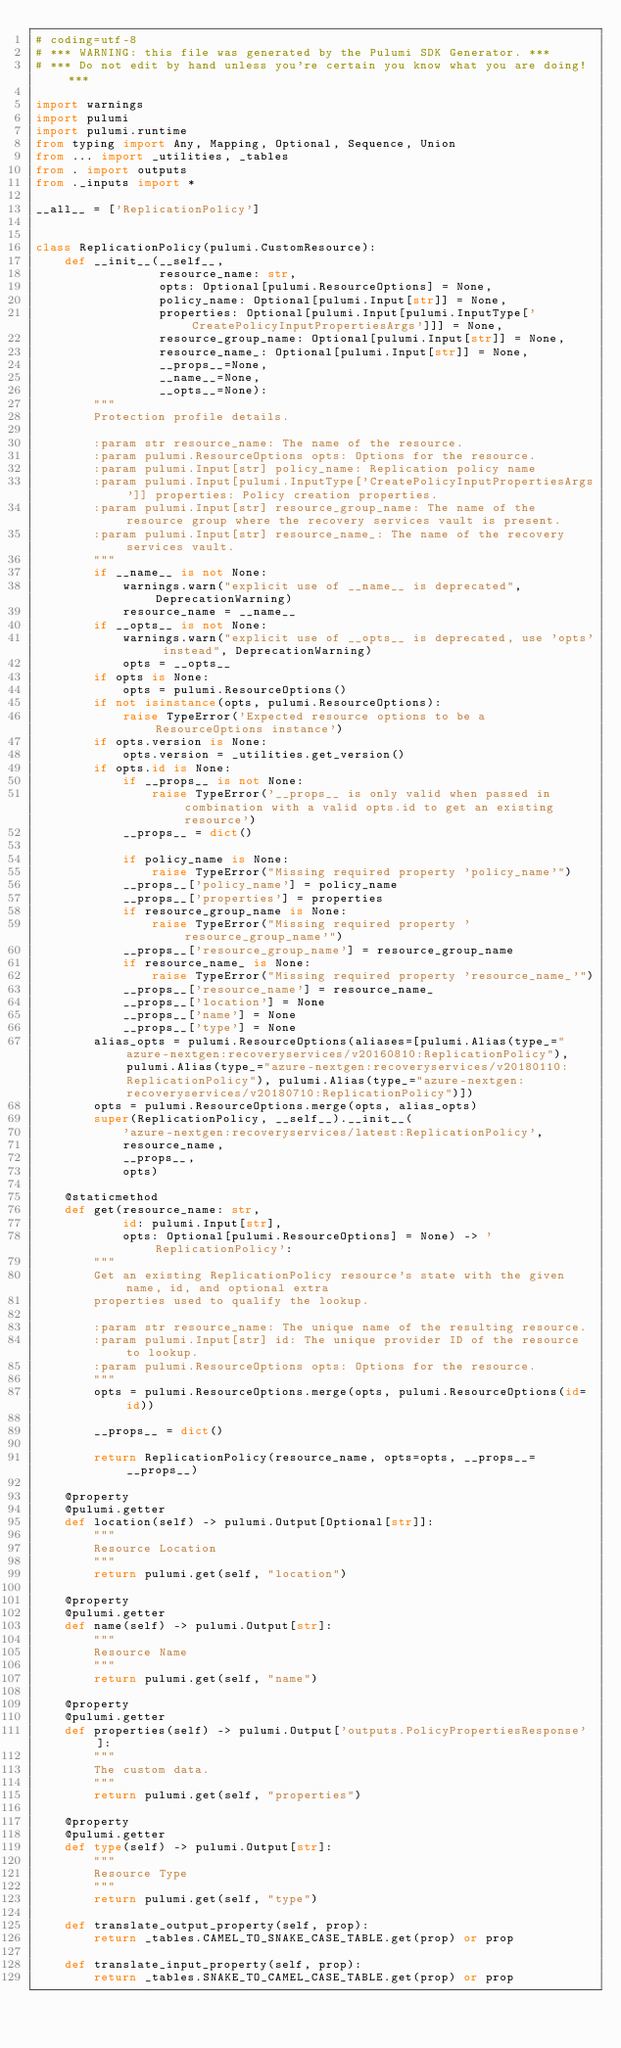<code> <loc_0><loc_0><loc_500><loc_500><_Python_># coding=utf-8
# *** WARNING: this file was generated by the Pulumi SDK Generator. ***
# *** Do not edit by hand unless you're certain you know what you are doing! ***

import warnings
import pulumi
import pulumi.runtime
from typing import Any, Mapping, Optional, Sequence, Union
from ... import _utilities, _tables
from . import outputs
from ._inputs import *

__all__ = ['ReplicationPolicy']


class ReplicationPolicy(pulumi.CustomResource):
    def __init__(__self__,
                 resource_name: str,
                 opts: Optional[pulumi.ResourceOptions] = None,
                 policy_name: Optional[pulumi.Input[str]] = None,
                 properties: Optional[pulumi.Input[pulumi.InputType['CreatePolicyInputPropertiesArgs']]] = None,
                 resource_group_name: Optional[pulumi.Input[str]] = None,
                 resource_name_: Optional[pulumi.Input[str]] = None,
                 __props__=None,
                 __name__=None,
                 __opts__=None):
        """
        Protection profile details.

        :param str resource_name: The name of the resource.
        :param pulumi.ResourceOptions opts: Options for the resource.
        :param pulumi.Input[str] policy_name: Replication policy name
        :param pulumi.Input[pulumi.InputType['CreatePolicyInputPropertiesArgs']] properties: Policy creation properties.
        :param pulumi.Input[str] resource_group_name: The name of the resource group where the recovery services vault is present.
        :param pulumi.Input[str] resource_name_: The name of the recovery services vault.
        """
        if __name__ is not None:
            warnings.warn("explicit use of __name__ is deprecated", DeprecationWarning)
            resource_name = __name__
        if __opts__ is not None:
            warnings.warn("explicit use of __opts__ is deprecated, use 'opts' instead", DeprecationWarning)
            opts = __opts__
        if opts is None:
            opts = pulumi.ResourceOptions()
        if not isinstance(opts, pulumi.ResourceOptions):
            raise TypeError('Expected resource options to be a ResourceOptions instance')
        if opts.version is None:
            opts.version = _utilities.get_version()
        if opts.id is None:
            if __props__ is not None:
                raise TypeError('__props__ is only valid when passed in combination with a valid opts.id to get an existing resource')
            __props__ = dict()

            if policy_name is None:
                raise TypeError("Missing required property 'policy_name'")
            __props__['policy_name'] = policy_name
            __props__['properties'] = properties
            if resource_group_name is None:
                raise TypeError("Missing required property 'resource_group_name'")
            __props__['resource_group_name'] = resource_group_name
            if resource_name_ is None:
                raise TypeError("Missing required property 'resource_name_'")
            __props__['resource_name'] = resource_name_
            __props__['location'] = None
            __props__['name'] = None
            __props__['type'] = None
        alias_opts = pulumi.ResourceOptions(aliases=[pulumi.Alias(type_="azure-nextgen:recoveryservices/v20160810:ReplicationPolicy"), pulumi.Alias(type_="azure-nextgen:recoveryservices/v20180110:ReplicationPolicy"), pulumi.Alias(type_="azure-nextgen:recoveryservices/v20180710:ReplicationPolicy")])
        opts = pulumi.ResourceOptions.merge(opts, alias_opts)
        super(ReplicationPolicy, __self__).__init__(
            'azure-nextgen:recoveryservices/latest:ReplicationPolicy',
            resource_name,
            __props__,
            opts)

    @staticmethod
    def get(resource_name: str,
            id: pulumi.Input[str],
            opts: Optional[pulumi.ResourceOptions] = None) -> 'ReplicationPolicy':
        """
        Get an existing ReplicationPolicy resource's state with the given name, id, and optional extra
        properties used to qualify the lookup.

        :param str resource_name: The unique name of the resulting resource.
        :param pulumi.Input[str] id: The unique provider ID of the resource to lookup.
        :param pulumi.ResourceOptions opts: Options for the resource.
        """
        opts = pulumi.ResourceOptions.merge(opts, pulumi.ResourceOptions(id=id))

        __props__ = dict()

        return ReplicationPolicy(resource_name, opts=opts, __props__=__props__)

    @property
    @pulumi.getter
    def location(self) -> pulumi.Output[Optional[str]]:
        """
        Resource Location
        """
        return pulumi.get(self, "location")

    @property
    @pulumi.getter
    def name(self) -> pulumi.Output[str]:
        """
        Resource Name
        """
        return pulumi.get(self, "name")

    @property
    @pulumi.getter
    def properties(self) -> pulumi.Output['outputs.PolicyPropertiesResponse']:
        """
        The custom data.
        """
        return pulumi.get(self, "properties")

    @property
    @pulumi.getter
    def type(self) -> pulumi.Output[str]:
        """
        Resource Type
        """
        return pulumi.get(self, "type")

    def translate_output_property(self, prop):
        return _tables.CAMEL_TO_SNAKE_CASE_TABLE.get(prop) or prop

    def translate_input_property(self, prop):
        return _tables.SNAKE_TO_CAMEL_CASE_TABLE.get(prop) or prop

</code> 